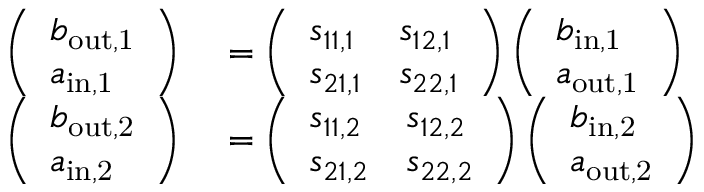<formula> <loc_0><loc_0><loc_500><loc_500>\begin{array} { r l } { \left ( \begin{array} { l } { b _ { o u t , 1 } } \\ { a _ { i n , 1 } } \end{array} \right ) } & = \left ( \begin{array} { l l } { s _ { 1 1 , 1 } } & { s _ { 1 2 , 1 } } \\ { s _ { 2 1 , 1 } } & { s _ { 2 2 , 1 } } \end{array} \right ) \left ( \begin{array} { l } { b _ { i n , 1 } } \\ { a _ { o u t , 1 } } \end{array} \right ) } \\ { \left ( \begin{array} { l } { b _ { o u t , 2 } } \\ { a _ { i n , 2 } } \end{array} \right ) } & = \left ( \begin{array} { l l } { s _ { 1 1 , 2 } } & { s _ { 1 2 , 2 } } \\ { s _ { 2 1 , 2 } } & { s _ { 2 2 , 2 } } \end{array} \right ) \left ( \begin{array} { l } { b _ { i n , 2 } } \\ { a _ { o u t , 2 } } \end{array} \right ) } \end{array}</formula> 